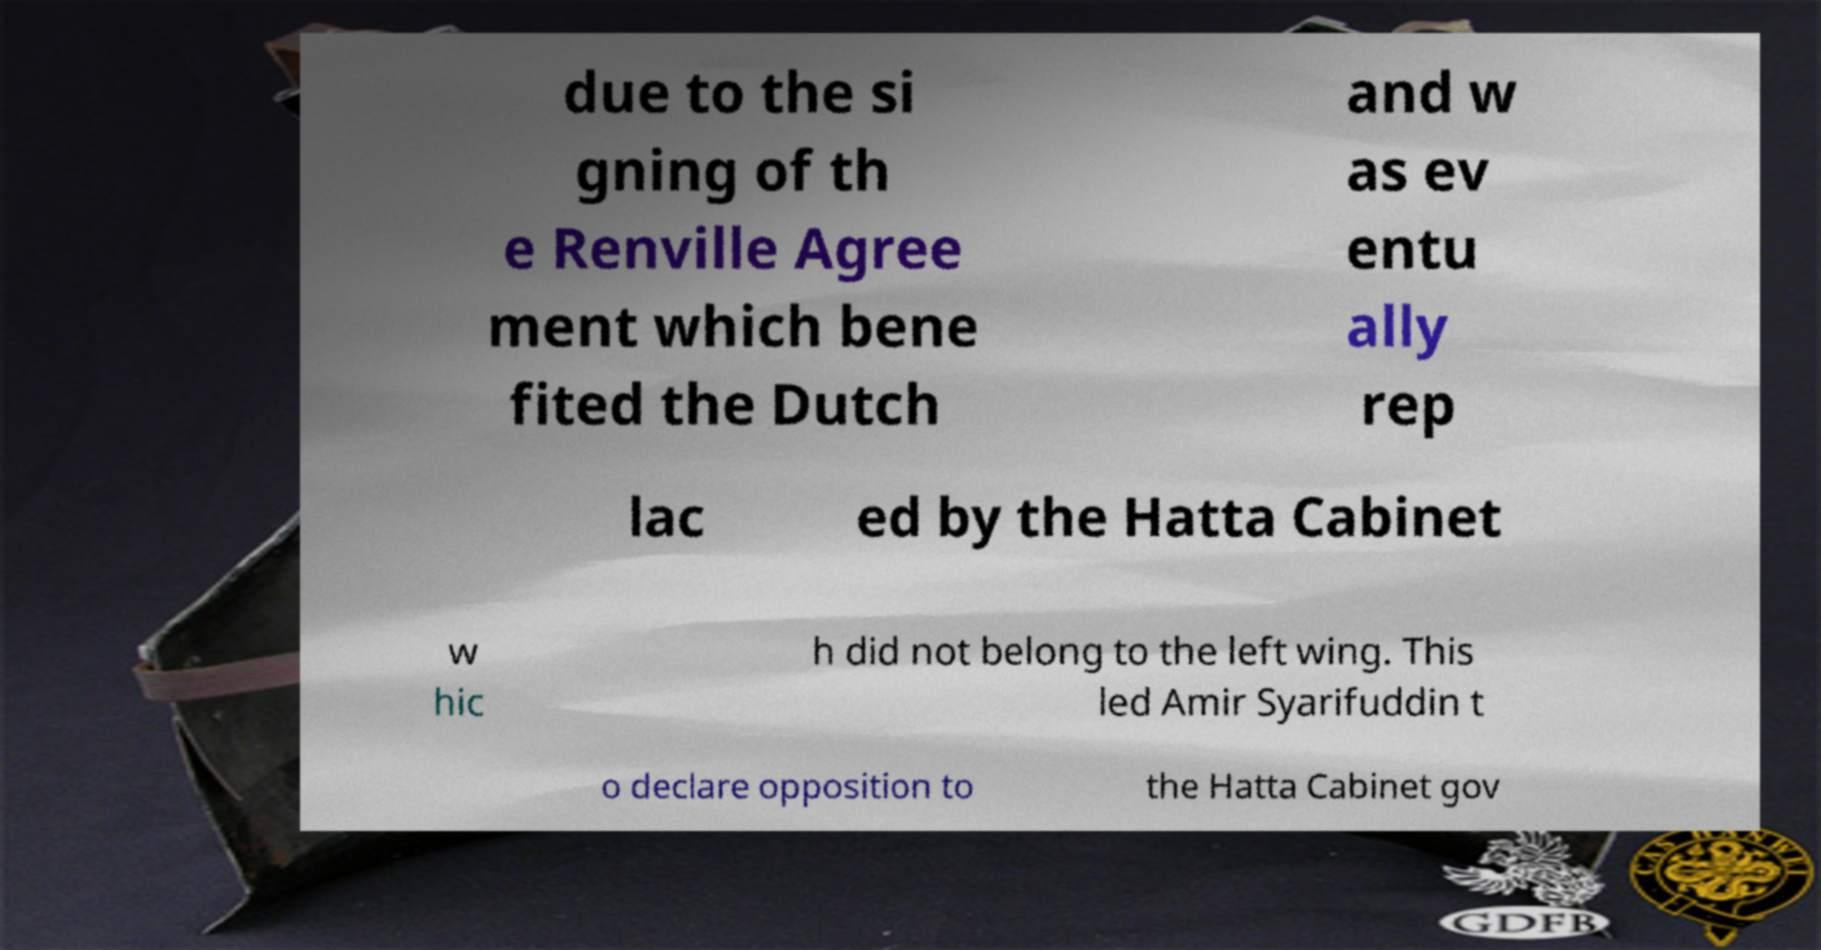Can you accurately transcribe the text from the provided image for me? due to the si gning of th e Renville Agree ment which bene fited the Dutch and w as ev entu ally rep lac ed by the Hatta Cabinet w hic h did not belong to the left wing. This led Amir Syarifuddin t o declare opposition to the Hatta Cabinet gov 